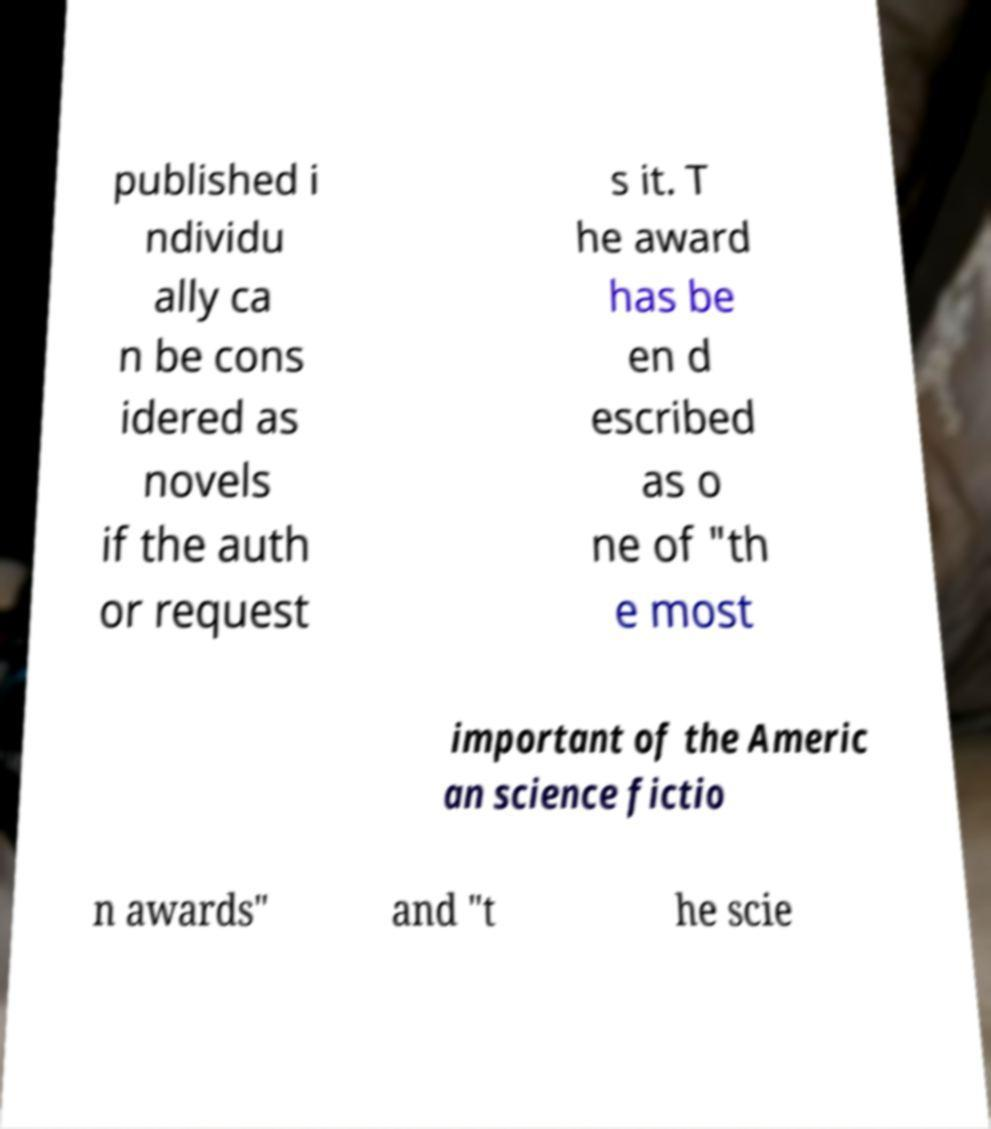Could you assist in decoding the text presented in this image and type it out clearly? published i ndividu ally ca n be cons idered as novels if the auth or request s it. T he award has be en d escribed as o ne of "th e most important of the Americ an science fictio n awards" and "t he scie 